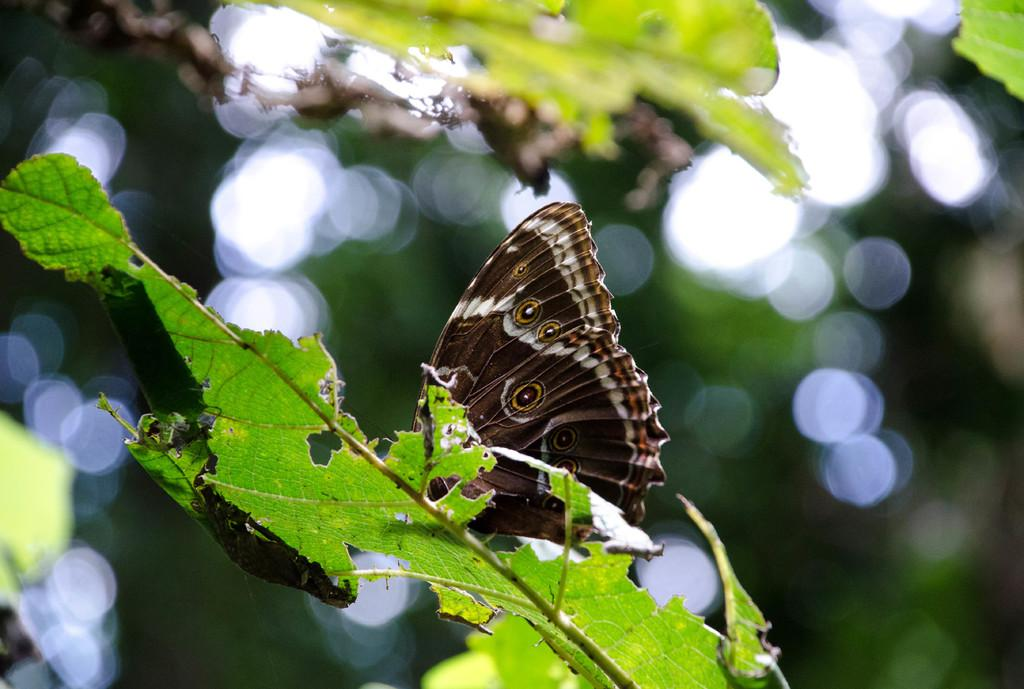What is the main subject of the image? There is a butterfly in the image. Where is the butterfly located? The butterfly is on a leaf. Can you describe the position of the leaf in the image? The leaf is in the center of the image. How would you describe the background of the image? The background of the image is blurry. What statement is being made by the butterfly in the image? There is no statement being made by the butterfly in the image, as it is a butterfly and not capable of making statements. 